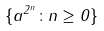Convert formula to latex. <formula><loc_0><loc_0><loc_500><loc_500>\{ a ^ { 2 ^ { n } } \colon n \geq 0 \}</formula> 